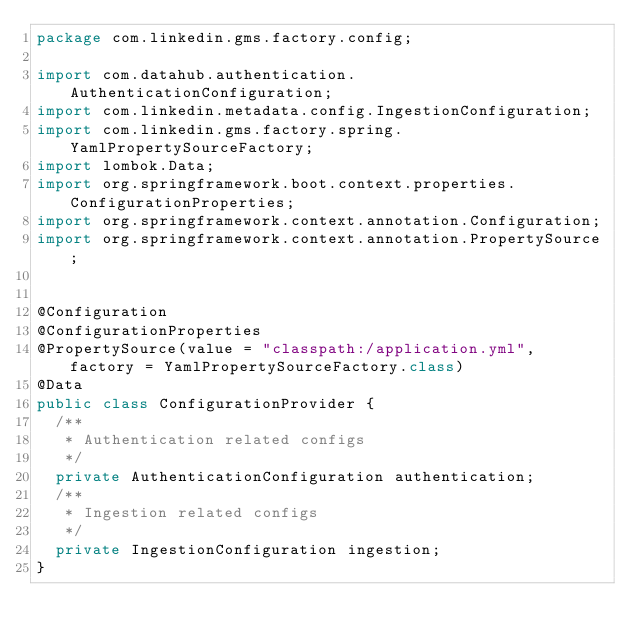<code> <loc_0><loc_0><loc_500><loc_500><_Java_>package com.linkedin.gms.factory.config;

import com.datahub.authentication.AuthenticationConfiguration;
import com.linkedin.metadata.config.IngestionConfiguration;
import com.linkedin.gms.factory.spring.YamlPropertySourceFactory;
import lombok.Data;
import org.springframework.boot.context.properties.ConfigurationProperties;
import org.springframework.context.annotation.Configuration;
import org.springframework.context.annotation.PropertySource;


@Configuration
@ConfigurationProperties
@PropertySource(value = "classpath:/application.yml", factory = YamlPropertySourceFactory.class)
@Data
public class ConfigurationProvider {
  /**
   * Authentication related configs
   */
  private AuthenticationConfiguration authentication;
  /**
   * Ingestion related configs
   */
  private IngestionConfiguration ingestion;
}</code> 